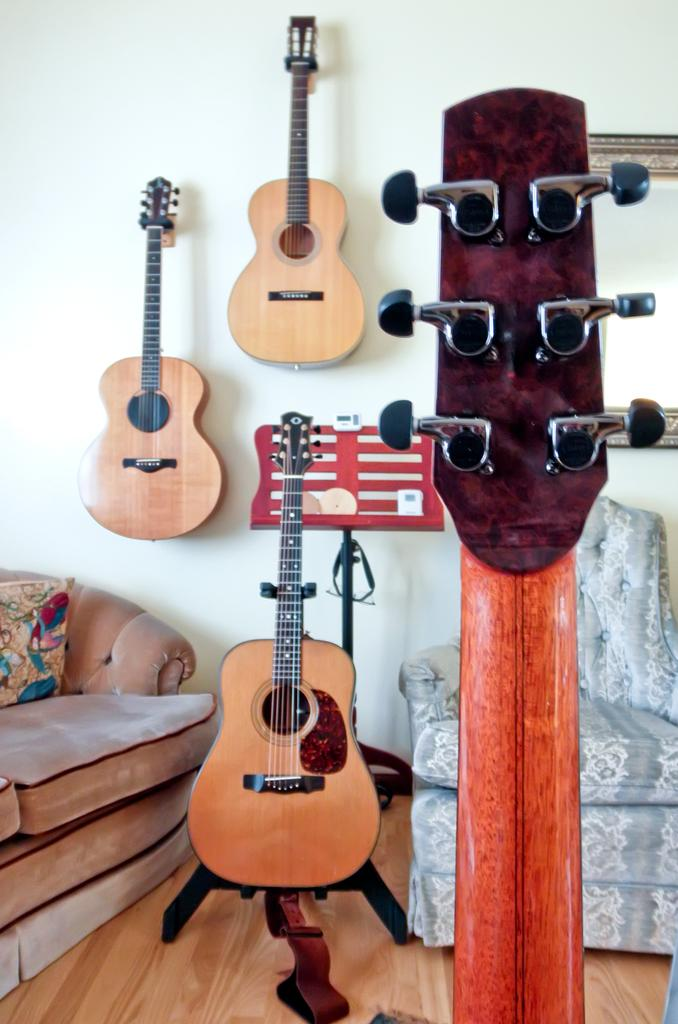What is the person in the image holding? The person in the image is holding a camera. What can be seen in the background of the image? There is a building in the background of the image. What type of discussion is taking place in the image? There is no discussion taking place in the image; it only shows a person holding a camera with a building in the background. 